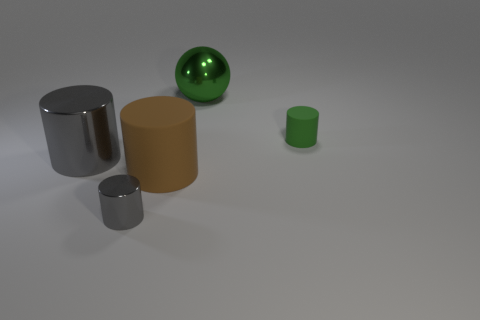Subtract 1 cylinders. How many cylinders are left? 3 Add 4 gray rubber balls. How many objects exist? 9 Subtract all balls. How many objects are left? 4 Subtract 0 cyan cylinders. How many objects are left? 5 Subtract all large green spheres. Subtract all big brown cylinders. How many objects are left? 3 Add 1 shiny spheres. How many shiny spheres are left? 2 Add 1 small shiny objects. How many small shiny objects exist? 2 